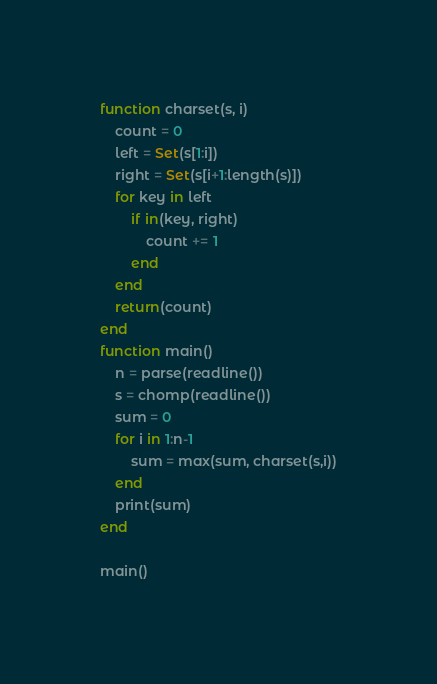<code> <loc_0><loc_0><loc_500><loc_500><_Julia_>function charset(s, i)
	count = 0
	left = Set(s[1:i])
	right = Set(s[i+1:length(s)])
	for key in left
		if in(key, right)
			count += 1
		end
	end
	return(count)
end
function main()
	n = parse(readline())
	s = chomp(readline())
	sum = 0
	for i in 1:n-1
		sum = max(sum, charset(s,i))
	end
	print(sum)
end

main()</code> 